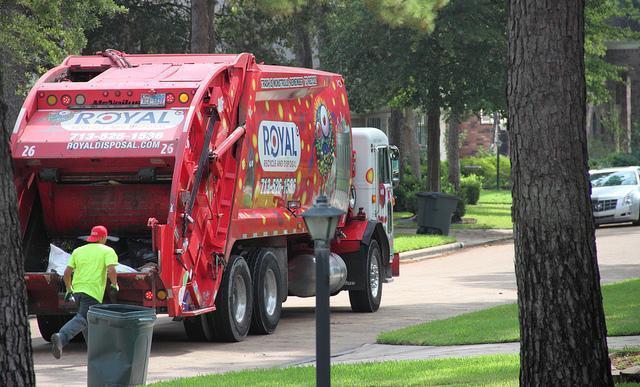What is being gathered by this vehicle?
Select the accurate answer and provide explanation: 'Answer: answer
Rationale: rationale.'
Options: Paper, children, ice cream, garbage. Answer: garbage.
Rationale: This is a trash truck. 